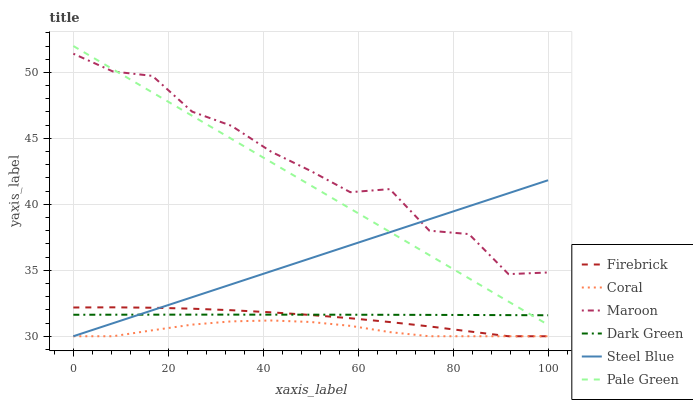Does Coral have the minimum area under the curve?
Answer yes or no. Yes. Does Maroon have the maximum area under the curve?
Answer yes or no. Yes. Does Steel Blue have the minimum area under the curve?
Answer yes or no. No. Does Steel Blue have the maximum area under the curve?
Answer yes or no. No. Is Pale Green the smoothest?
Answer yes or no. Yes. Is Maroon the roughest?
Answer yes or no. Yes. Is Steel Blue the smoothest?
Answer yes or no. No. Is Steel Blue the roughest?
Answer yes or no. No. Does Firebrick have the lowest value?
Answer yes or no. Yes. Does Maroon have the lowest value?
Answer yes or no. No. Does Pale Green have the highest value?
Answer yes or no. Yes. Does Steel Blue have the highest value?
Answer yes or no. No. Is Coral less than Pale Green?
Answer yes or no. Yes. Is Maroon greater than Coral?
Answer yes or no. Yes. Does Firebrick intersect Coral?
Answer yes or no. Yes. Is Firebrick less than Coral?
Answer yes or no. No. Is Firebrick greater than Coral?
Answer yes or no. No. Does Coral intersect Pale Green?
Answer yes or no. No. 